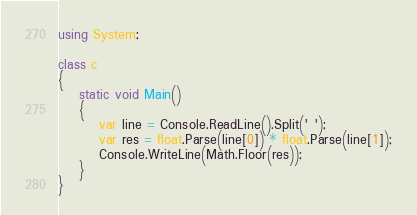<code> <loc_0><loc_0><loc_500><loc_500><_C#_>using System;

class c
{
    static void Main()
    {
        var line = Console.ReadLine().Split(' ');
        var res = float.Parse(line[0]) * float.Parse(line[1]);
        Console.WriteLine(Math.Floor(res));
    }
}</code> 